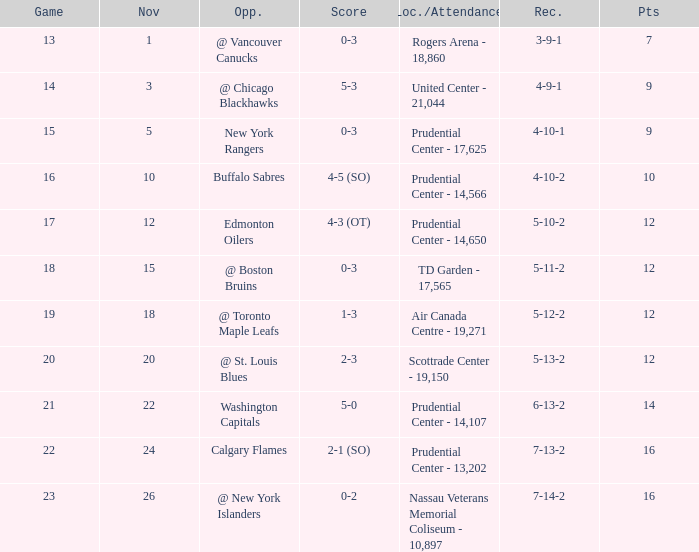Can you parse all the data within this table? {'header': ['Game', 'Nov', 'Opp.', 'Score', 'Loc./Attendance', 'Rec.', 'Pts'], 'rows': [['13', '1', '@ Vancouver Canucks', '0-3', 'Rogers Arena - 18,860', '3-9-1', '7'], ['14', '3', '@ Chicago Blackhawks', '5-3', 'United Center - 21,044', '4-9-1', '9'], ['15', '5', 'New York Rangers', '0-3', 'Prudential Center - 17,625', '4-10-1', '9'], ['16', '10', 'Buffalo Sabres', '4-5 (SO)', 'Prudential Center - 14,566', '4-10-2', '10'], ['17', '12', 'Edmonton Oilers', '4-3 (OT)', 'Prudential Center - 14,650', '5-10-2', '12'], ['18', '15', '@ Boston Bruins', '0-3', 'TD Garden - 17,565', '5-11-2', '12'], ['19', '18', '@ Toronto Maple Leafs', '1-3', 'Air Canada Centre - 19,271', '5-12-2', '12'], ['20', '20', '@ St. Louis Blues', '2-3', 'Scottrade Center - 19,150', '5-13-2', '12'], ['21', '22', 'Washington Capitals', '5-0', 'Prudential Center - 14,107', '6-13-2', '14'], ['22', '24', 'Calgary Flames', '2-1 (SO)', 'Prudential Center - 13,202', '7-13-2', '16'], ['23', '26', '@ New York Islanders', '0-2', 'Nassau Veterans Memorial Coliseum - 10,897', '7-14-2', '16']]} Who was the opponent where the game is 14? @ Chicago Blackhawks. 